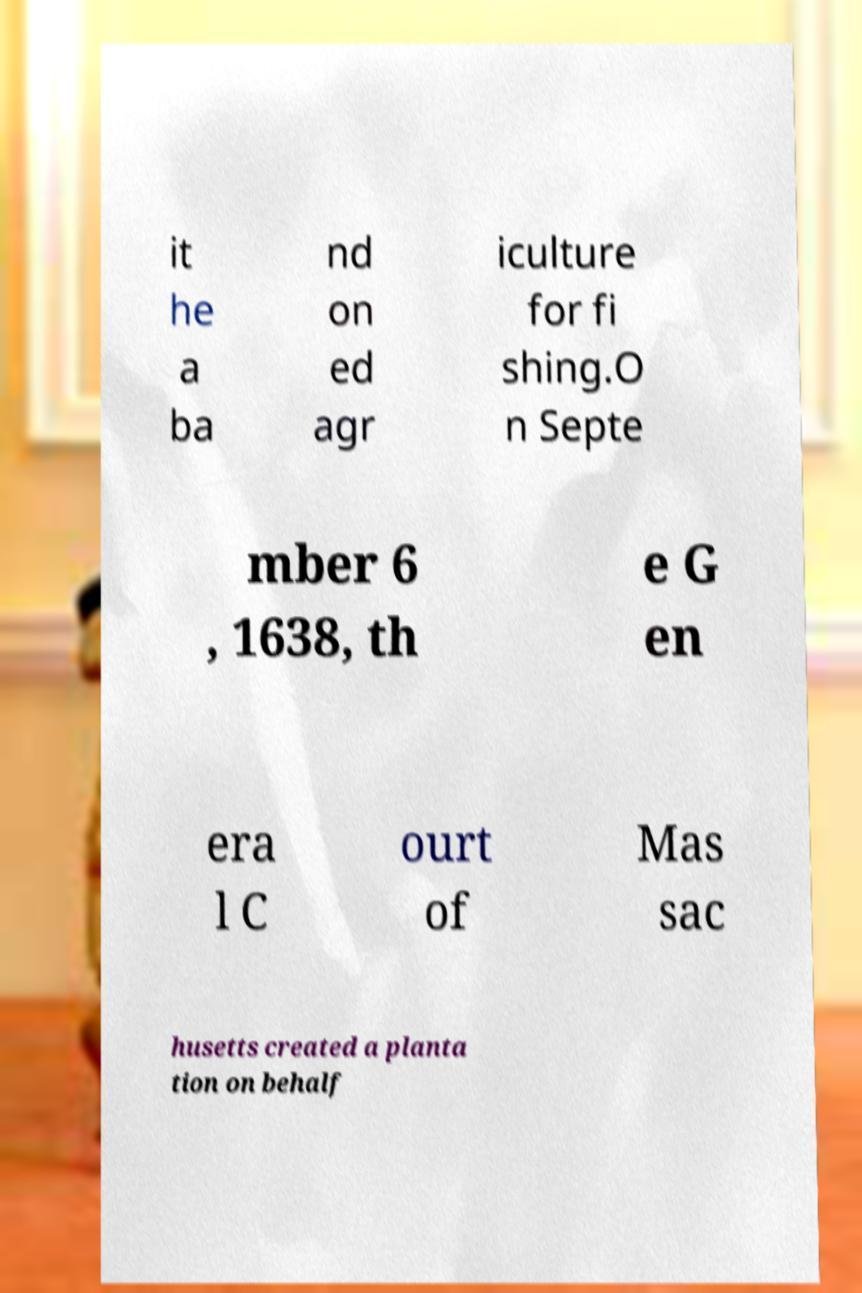There's text embedded in this image that I need extracted. Can you transcribe it verbatim? it he a ba nd on ed agr iculture for fi shing.O n Septe mber 6 , 1638, th e G en era l C ourt of Mas sac husetts created a planta tion on behalf 